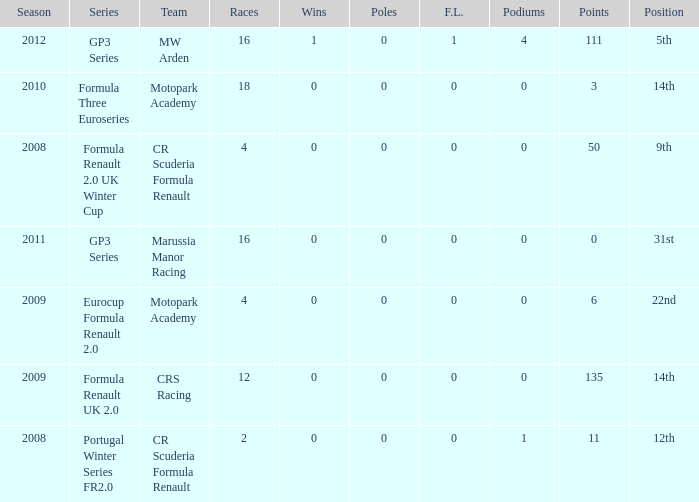What are the most poles listed? 0.0. 